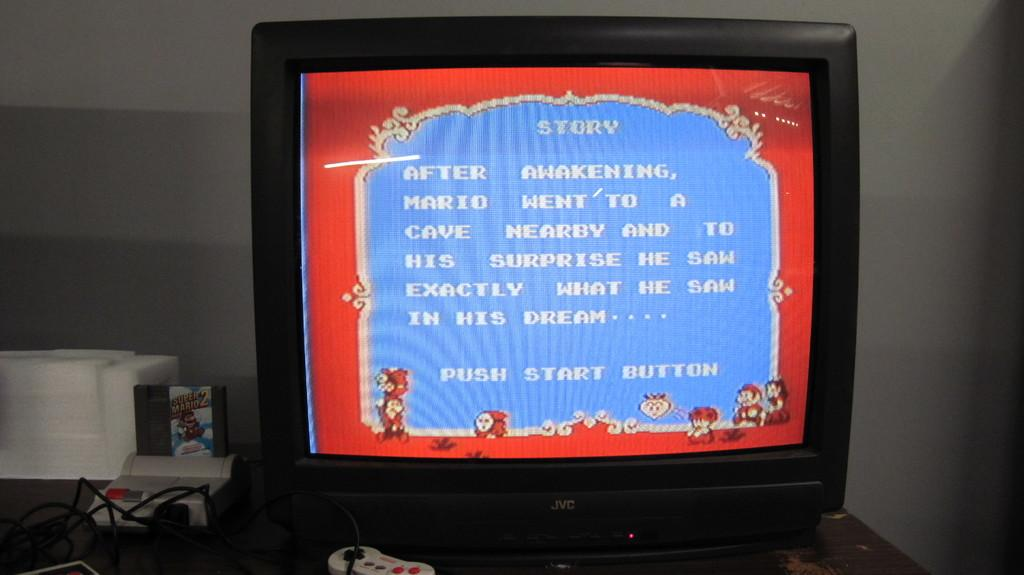<image>
Render a clear and concise summary of the photo. An old JVC television has a story written on it. 